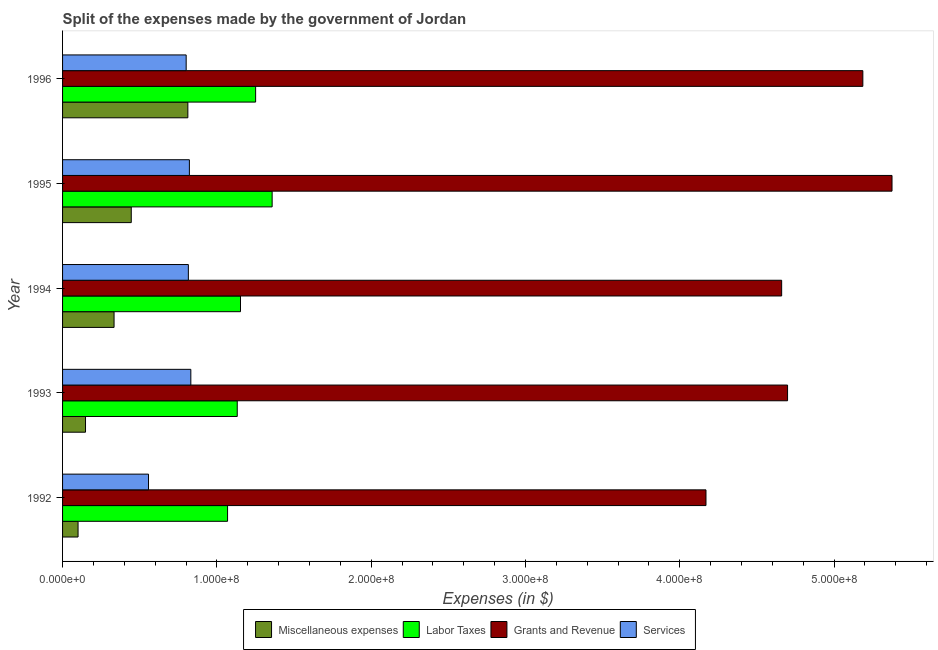How many different coloured bars are there?
Provide a short and direct response. 4. How many bars are there on the 1st tick from the top?
Your answer should be compact. 4. What is the label of the 3rd group of bars from the top?
Give a very brief answer. 1994. In how many cases, is the number of bars for a given year not equal to the number of legend labels?
Your answer should be very brief. 0. What is the amount spent on miscellaneous expenses in 1996?
Provide a short and direct response. 8.12e+07. Across all years, what is the maximum amount spent on services?
Your response must be concise. 8.31e+07. Across all years, what is the minimum amount spent on miscellaneous expenses?
Offer a very short reply. 1.00e+07. In which year was the amount spent on grants and revenue maximum?
Ensure brevity in your answer.  1995. In which year was the amount spent on services minimum?
Keep it short and to the point. 1992. What is the total amount spent on labor taxes in the graph?
Keep it short and to the point. 5.96e+08. What is the difference between the amount spent on labor taxes in 1993 and that in 1995?
Make the answer very short. -2.26e+07. What is the difference between the amount spent on services in 1993 and the amount spent on grants and revenue in 1996?
Offer a very short reply. -4.36e+08. What is the average amount spent on services per year?
Provide a succinct answer. 7.65e+07. In the year 1993, what is the difference between the amount spent on labor taxes and amount spent on grants and revenue?
Keep it short and to the point. -3.57e+08. What is the ratio of the amount spent on grants and revenue in 1993 to that in 1996?
Your answer should be very brief. 0.91. Is the amount spent on labor taxes in 1994 less than that in 1995?
Your response must be concise. Yes. What is the difference between the highest and the second highest amount spent on services?
Your answer should be compact. 9.30e+05. What is the difference between the highest and the lowest amount spent on miscellaneous expenses?
Keep it short and to the point. 7.12e+07. What does the 4th bar from the top in 1995 represents?
Keep it short and to the point. Miscellaneous expenses. What does the 1st bar from the bottom in 1996 represents?
Give a very brief answer. Miscellaneous expenses. How many bars are there?
Provide a short and direct response. 20. Are the values on the major ticks of X-axis written in scientific E-notation?
Your answer should be compact. Yes. Does the graph contain any zero values?
Your answer should be very brief. No. Does the graph contain grids?
Provide a succinct answer. No. Where does the legend appear in the graph?
Provide a succinct answer. Bottom center. What is the title of the graph?
Provide a succinct answer. Split of the expenses made by the government of Jordan. Does "Social Assistance" appear as one of the legend labels in the graph?
Give a very brief answer. No. What is the label or title of the X-axis?
Provide a succinct answer. Expenses (in $). What is the label or title of the Y-axis?
Your response must be concise. Year. What is the Expenses (in $) of Miscellaneous expenses in 1992?
Your response must be concise. 1.00e+07. What is the Expenses (in $) in Labor Taxes in 1992?
Provide a succinct answer. 1.07e+08. What is the Expenses (in $) in Grants and Revenue in 1992?
Your answer should be very brief. 4.17e+08. What is the Expenses (in $) in Services in 1992?
Provide a succinct answer. 5.57e+07. What is the Expenses (in $) of Miscellaneous expenses in 1993?
Make the answer very short. 1.49e+07. What is the Expenses (in $) of Labor Taxes in 1993?
Provide a succinct answer. 1.13e+08. What is the Expenses (in $) of Grants and Revenue in 1993?
Make the answer very short. 4.70e+08. What is the Expenses (in $) in Services in 1993?
Provide a short and direct response. 8.31e+07. What is the Expenses (in $) in Miscellaneous expenses in 1994?
Your response must be concise. 3.34e+07. What is the Expenses (in $) of Labor Taxes in 1994?
Give a very brief answer. 1.15e+08. What is the Expenses (in $) in Grants and Revenue in 1994?
Provide a succinct answer. 4.66e+08. What is the Expenses (in $) in Services in 1994?
Offer a terse response. 8.15e+07. What is the Expenses (in $) of Miscellaneous expenses in 1995?
Ensure brevity in your answer.  4.45e+07. What is the Expenses (in $) of Labor Taxes in 1995?
Your answer should be compact. 1.36e+08. What is the Expenses (in $) of Grants and Revenue in 1995?
Provide a succinct answer. 5.38e+08. What is the Expenses (in $) in Services in 1995?
Give a very brief answer. 8.22e+07. What is the Expenses (in $) of Miscellaneous expenses in 1996?
Your answer should be compact. 8.12e+07. What is the Expenses (in $) in Labor Taxes in 1996?
Offer a terse response. 1.25e+08. What is the Expenses (in $) in Grants and Revenue in 1996?
Give a very brief answer. 5.19e+08. What is the Expenses (in $) in Services in 1996?
Offer a terse response. 8.01e+07. Across all years, what is the maximum Expenses (in $) of Miscellaneous expenses?
Give a very brief answer. 8.12e+07. Across all years, what is the maximum Expenses (in $) of Labor Taxes?
Your answer should be compact. 1.36e+08. Across all years, what is the maximum Expenses (in $) of Grants and Revenue?
Give a very brief answer. 5.38e+08. Across all years, what is the maximum Expenses (in $) in Services?
Provide a succinct answer. 8.31e+07. Across all years, what is the minimum Expenses (in $) of Miscellaneous expenses?
Offer a very short reply. 1.00e+07. Across all years, what is the minimum Expenses (in $) in Labor Taxes?
Your response must be concise. 1.07e+08. Across all years, what is the minimum Expenses (in $) in Grants and Revenue?
Keep it short and to the point. 4.17e+08. Across all years, what is the minimum Expenses (in $) of Services?
Keep it short and to the point. 5.57e+07. What is the total Expenses (in $) in Miscellaneous expenses in the graph?
Ensure brevity in your answer.  1.84e+08. What is the total Expenses (in $) of Labor Taxes in the graph?
Make the answer very short. 5.96e+08. What is the total Expenses (in $) in Grants and Revenue in the graph?
Make the answer very short. 2.41e+09. What is the total Expenses (in $) of Services in the graph?
Give a very brief answer. 3.83e+08. What is the difference between the Expenses (in $) in Miscellaneous expenses in 1992 and that in 1993?
Your response must be concise. -4.83e+06. What is the difference between the Expenses (in $) of Labor Taxes in 1992 and that in 1993?
Your answer should be compact. -6.27e+06. What is the difference between the Expenses (in $) of Grants and Revenue in 1992 and that in 1993?
Offer a very short reply. -5.29e+07. What is the difference between the Expenses (in $) in Services in 1992 and that in 1993?
Provide a succinct answer. -2.74e+07. What is the difference between the Expenses (in $) of Miscellaneous expenses in 1992 and that in 1994?
Keep it short and to the point. -2.33e+07. What is the difference between the Expenses (in $) of Labor Taxes in 1992 and that in 1994?
Your answer should be very brief. -8.38e+06. What is the difference between the Expenses (in $) in Grants and Revenue in 1992 and that in 1994?
Offer a terse response. -4.90e+07. What is the difference between the Expenses (in $) of Services in 1992 and that in 1994?
Your answer should be compact. -2.58e+07. What is the difference between the Expenses (in $) of Miscellaneous expenses in 1992 and that in 1995?
Offer a terse response. -3.45e+07. What is the difference between the Expenses (in $) of Labor Taxes in 1992 and that in 1995?
Provide a succinct answer. -2.89e+07. What is the difference between the Expenses (in $) in Grants and Revenue in 1992 and that in 1995?
Keep it short and to the point. -1.21e+08. What is the difference between the Expenses (in $) in Services in 1992 and that in 1995?
Your response must be concise. -2.65e+07. What is the difference between the Expenses (in $) in Miscellaneous expenses in 1992 and that in 1996?
Offer a very short reply. -7.12e+07. What is the difference between the Expenses (in $) of Labor Taxes in 1992 and that in 1996?
Offer a very short reply. -1.82e+07. What is the difference between the Expenses (in $) in Grants and Revenue in 1992 and that in 1996?
Keep it short and to the point. -1.02e+08. What is the difference between the Expenses (in $) of Services in 1992 and that in 1996?
Make the answer very short. -2.44e+07. What is the difference between the Expenses (in $) in Miscellaneous expenses in 1993 and that in 1994?
Ensure brevity in your answer.  -1.85e+07. What is the difference between the Expenses (in $) of Labor Taxes in 1993 and that in 1994?
Keep it short and to the point. -2.11e+06. What is the difference between the Expenses (in $) in Grants and Revenue in 1993 and that in 1994?
Offer a very short reply. 3.83e+06. What is the difference between the Expenses (in $) of Services in 1993 and that in 1994?
Offer a very short reply. 1.60e+06. What is the difference between the Expenses (in $) in Miscellaneous expenses in 1993 and that in 1995?
Keep it short and to the point. -2.96e+07. What is the difference between the Expenses (in $) in Labor Taxes in 1993 and that in 1995?
Offer a terse response. -2.26e+07. What is the difference between the Expenses (in $) of Grants and Revenue in 1993 and that in 1995?
Provide a short and direct response. -6.77e+07. What is the difference between the Expenses (in $) in Services in 1993 and that in 1995?
Ensure brevity in your answer.  9.30e+05. What is the difference between the Expenses (in $) in Miscellaneous expenses in 1993 and that in 1996?
Your answer should be compact. -6.63e+07. What is the difference between the Expenses (in $) of Labor Taxes in 1993 and that in 1996?
Ensure brevity in your answer.  -1.19e+07. What is the difference between the Expenses (in $) in Grants and Revenue in 1993 and that in 1996?
Your answer should be very brief. -4.88e+07. What is the difference between the Expenses (in $) in Services in 1993 and that in 1996?
Make the answer very short. 3.02e+06. What is the difference between the Expenses (in $) of Miscellaneous expenses in 1994 and that in 1995?
Provide a short and direct response. -1.12e+07. What is the difference between the Expenses (in $) of Labor Taxes in 1994 and that in 1995?
Give a very brief answer. -2.05e+07. What is the difference between the Expenses (in $) in Grants and Revenue in 1994 and that in 1995?
Your answer should be compact. -7.15e+07. What is the difference between the Expenses (in $) of Services in 1994 and that in 1995?
Give a very brief answer. -6.70e+05. What is the difference between the Expenses (in $) of Miscellaneous expenses in 1994 and that in 1996?
Give a very brief answer. -4.78e+07. What is the difference between the Expenses (in $) of Labor Taxes in 1994 and that in 1996?
Offer a very short reply. -9.80e+06. What is the difference between the Expenses (in $) of Grants and Revenue in 1994 and that in 1996?
Give a very brief answer. -5.26e+07. What is the difference between the Expenses (in $) of Services in 1994 and that in 1996?
Give a very brief answer. 1.42e+06. What is the difference between the Expenses (in $) in Miscellaneous expenses in 1995 and that in 1996?
Provide a short and direct response. -3.67e+07. What is the difference between the Expenses (in $) in Labor Taxes in 1995 and that in 1996?
Provide a succinct answer. 1.07e+07. What is the difference between the Expenses (in $) in Grants and Revenue in 1995 and that in 1996?
Your response must be concise. 1.89e+07. What is the difference between the Expenses (in $) of Services in 1995 and that in 1996?
Ensure brevity in your answer.  2.09e+06. What is the difference between the Expenses (in $) of Miscellaneous expenses in 1992 and the Expenses (in $) of Labor Taxes in 1993?
Provide a short and direct response. -1.03e+08. What is the difference between the Expenses (in $) in Miscellaneous expenses in 1992 and the Expenses (in $) in Grants and Revenue in 1993?
Provide a succinct answer. -4.60e+08. What is the difference between the Expenses (in $) of Miscellaneous expenses in 1992 and the Expenses (in $) of Services in 1993?
Your response must be concise. -7.31e+07. What is the difference between the Expenses (in $) of Labor Taxes in 1992 and the Expenses (in $) of Grants and Revenue in 1993?
Your answer should be compact. -3.63e+08. What is the difference between the Expenses (in $) in Labor Taxes in 1992 and the Expenses (in $) in Services in 1993?
Give a very brief answer. 2.38e+07. What is the difference between the Expenses (in $) of Grants and Revenue in 1992 and the Expenses (in $) of Services in 1993?
Offer a terse response. 3.34e+08. What is the difference between the Expenses (in $) in Miscellaneous expenses in 1992 and the Expenses (in $) in Labor Taxes in 1994?
Your answer should be compact. -1.05e+08. What is the difference between the Expenses (in $) in Miscellaneous expenses in 1992 and the Expenses (in $) in Grants and Revenue in 1994?
Offer a terse response. -4.56e+08. What is the difference between the Expenses (in $) of Miscellaneous expenses in 1992 and the Expenses (in $) of Services in 1994?
Your response must be concise. -7.15e+07. What is the difference between the Expenses (in $) in Labor Taxes in 1992 and the Expenses (in $) in Grants and Revenue in 1994?
Offer a very short reply. -3.59e+08. What is the difference between the Expenses (in $) of Labor Taxes in 1992 and the Expenses (in $) of Services in 1994?
Offer a very short reply. 2.54e+07. What is the difference between the Expenses (in $) of Grants and Revenue in 1992 and the Expenses (in $) of Services in 1994?
Provide a succinct answer. 3.35e+08. What is the difference between the Expenses (in $) of Miscellaneous expenses in 1992 and the Expenses (in $) of Labor Taxes in 1995?
Provide a short and direct response. -1.26e+08. What is the difference between the Expenses (in $) of Miscellaneous expenses in 1992 and the Expenses (in $) of Grants and Revenue in 1995?
Give a very brief answer. -5.27e+08. What is the difference between the Expenses (in $) in Miscellaneous expenses in 1992 and the Expenses (in $) in Services in 1995?
Offer a very short reply. -7.22e+07. What is the difference between the Expenses (in $) of Labor Taxes in 1992 and the Expenses (in $) of Grants and Revenue in 1995?
Your answer should be compact. -4.31e+08. What is the difference between the Expenses (in $) of Labor Taxes in 1992 and the Expenses (in $) of Services in 1995?
Make the answer very short. 2.47e+07. What is the difference between the Expenses (in $) in Grants and Revenue in 1992 and the Expenses (in $) in Services in 1995?
Offer a very short reply. 3.35e+08. What is the difference between the Expenses (in $) of Miscellaneous expenses in 1992 and the Expenses (in $) of Labor Taxes in 1996?
Offer a terse response. -1.15e+08. What is the difference between the Expenses (in $) in Miscellaneous expenses in 1992 and the Expenses (in $) in Grants and Revenue in 1996?
Give a very brief answer. -5.09e+08. What is the difference between the Expenses (in $) of Miscellaneous expenses in 1992 and the Expenses (in $) of Services in 1996?
Keep it short and to the point. -7.01e+07. What is the difference between the Expenses (in $) of Labor Taxes in 1992 and the Expenses (in $) of Grants and Revenue in 1996?
Keep it short and to the point. -4.12e+08. What is the difference between the Expenses (in $) in Labor Taxes in 1992 and the Expenses (in $) in Services in 1996?
Your answer should be compact. 2.68e+07. What is the difference between the Expenses (in $) in Grants and Revenue in 1992 and the Expenses (in $) in Services in 1996?
Your answer should be compact. 3.37e+08. What is the difference between the Expenses (in $) of Miscellaneous expenses in 1993 and the Expenses (in $) of Labor Taxes in 1994?
Offer a very short reply. -1.00e+08. What is the difference between the Expenses (in $) of Miscellaneous expenses in 1993 and the Expenses (in $) of Grants and Revenue in 1994?
Keep it short and to the point. -4.51e+08. What is the difference between the Expenses (in $) of Miscellaneous expenses in 1993 and the Expenses (in $) of Services in 1994?
Your answer should be compact. -6.66e+07. What is the difference between the Expenses (in $) of Labor Taxes in 1993 and the Expenses (in $) of Grants and Revenue in 1994?
Keep it short and to the point. -3.53e+08. What is the difference between the Expenses (in $) in Labor Taxes in 1993 and the Expenses (in $) in Services in 1994?
Keep it short and to the point. 3.17e+07. What is the difference between the Expenses (in $) in Grants and Revenue in 1993 and the Expenses (in $) in Services in 1994?
Keep it short and to the point. 3.88e+08. What is the difference between the Expenses (in $) in Miscellaneous expenses in 1993 and the Expenses (in $) in Labor Taxes in 1995?
Provide a succinct answer. -1.21e+08. What is the difference between the Expenses (in $) in Miscellaneous expenses in 1993 and the Expenses (in $) in Grants and Revenue in 1995?
Your answer should be compact. -5.23e+08. What is the difference between the Expenses (in $) of Miscellaneous expenses in 1993 and the Expenses (in $) of Services in 1995?
Provide a short and direct response. -6.73e+07. What is the difference between the Expenses (in $) in Labor Taxes in 1993 and the Expenses (in $) in Grants and Revenue in 1995?
Provide a short and direct response. -4.24e+08. What is the difference between the Expenses (in $) in Labor Taxes in 1993 and the Expenses (in $) in Services in 1995?
Make the answer very short. 3.10e+07. What is the difference between the Expenses (in $) in Grants and Revenue in 1993 and the Expenses (in $) in Services in 1995?
Make the answer very short. 3.88e+08. What is the difference between the Expenses (in $) of Miscellaneous expenses in 1993 and the Expenses (in $) of Labor Taxes in 1996?
Your answer should be very brief. -1.10e+08. What is the difference between the Expenses (in $) in Miscellaneous expenses in 1993 and the Expenses (in $) in Grants and Revenue in 1996?
Keep it short and to the point. -5.04e+08. What is the difference between the Expenses (in $) in Miscellaneous expenses in 1993 and the Expenses (in $) in Services in 1996?
Your answer should be very brief. -6.52e+07. What is the difference between the Expenses (in $) in Labor Taxes in 1993 and the Expenses (in $) in Grants and Revenue in 1996?
Give a very brief answer. -4.05e+08. What is the difference between the Expenses (in $) of Labor Taxes in 1993 and the Expenses (in $) of Services in 1996?
Your answer should be compact. 3.31e+07. What is the difference between the Expenses (in $) of Grants and Revenue in 1993 and the Expenses (in $) of Services in 1996?
Keep it short and to the point. 3.90e+08. What is the difference between the Expenses (in $) in Miscellaneous expenses in 1994 and the Expenses (in $) in Labor Taxes in 1995?
Offer a terse response. -1.02e+08. What is the difference between the Expenses (in $) in Miscellaneous expenses in 1994 and the Expenses (in $) in Grants and Revenue in 1995?
Ensure brevity in your answer.  -5.04e+08. What is the difference between the Expenses (in $) in Miscellaneous expenses in 1994 and the Expenses (in $) in Services in 1995?
Keep it short and to the point. -4.88e+07. What is the difference between the Expenses (in $) in Labor Taxes in 1994 and the Expenses (in $) in Grants and Revenue in 1995?
Offer a terse response. -4.22e+08. What is the difference between the Expenses (in $) in Labor Taxes in 1994 and the Expenses (in $) in Services in 1995?
Provide a succinct answer. 3.31e+07. What is the difference between the Expenses (in $) in Grants and Revenue in 1994 and the Expenses (in $) in Services in 1995?
Provide a succinct answer. 3.84e+08. What is the difference between the Expenses (in $) of Miscellaneous expenses in 1994 and the Expenses (in $) of Labor Taxes in 1996?
Your answer should be compact. -9.17e+07. What is the difference between the Expenses (in $) in Miscellaneous expenses in 1994 and the Expenses (in $) in Grants and Revenue in 1996?
Offer a very short reply. -4.85e+08. What is the difference between the Expenses (in $) in Miscellaneous expenses in 1994 and the Expenses (in $) in Services in 1996?
Ensure brevity in your answer.  -4.67e+07. What is the difference between the Expenses (in $) of Labor Taxes in 1994 and the Expenses (in $) of Grants and Revenue in 1996?
Provide a short and direct response. -4.03e+08. What is the difference between the Expenses (in $) in Labor Taxes in 1994 and the Expenses (in $) in Services in 1996?
Give a very brief answer. 3.52e+07. What is the difference between the Expenses (in $) in Grants and Revenue in 1994 and the Expenses (in $) in Services in 1996?
Ensure brevity in your answer.  3.86e+08. What is the difference between the Expenses (in $) in Miscellaneous expenses in 1995 and the Expenses (in $) in Labor Taxes in 1996?
Offer a terse response. -8.06e+07. What is the difference between the Expenses (in $) in Miscellaneous expenses in 1995 and the Expenses (in $) in Grants and Revenue in 1996?
Make the answer very short. -4.74e+08. What is the difference between the Expenses (in $) in Miscellaneous expenses in 1995 and the Expenses (in $) in Services in 1996?
Your response must be concise. -3.56e+07. What is the difference between the Expenses (in $) in Labor Taxes in 1995 and the Expenses (in $) in Grants and Revenue in 1996?
Make the answer very short. -3.83e+08. What is the difference between the Expenses (in $) of Labor Taxes in 1995 and the Expenses (in $) of Services in 1996?
Your response must be concise. 5.57e+07. What is the difference between the Expenses (in $) in Grants and Revenue in 1995 and the Expenses (in $) in Services in 1996?
Give a very brief answer. 4.57e+08. What is the average Expenses (in $) in Miscellaneous expenses per year?
Your response must be concise. 3.68e+07. What is the average Expenses (in $) of Labor Taxes per year?
Provide a succinct answer. 1.19e+08. What is the average Expenses (in $) of Grants and Revenue per year?
Offer a very short reply. 4.82e+08. What is the average Expenses (in $) of Services per year?
Keep it short and to the point. 7.65e+07. In the year 1992, what is the difference between the Expenses (in $) in Miscellaneous expenses and Expenses (in $) in Labor Taxes?
Keep it short and to the point. -9.69e+07. In the year 1992, what is the difference between the Expenses (in $) in Miscellaneous expenses and Expenses (in $) in Grants and Revenue?
Keep it short and to the point. -4.07e+08. In the year 1992, what is the difference between the Expenses (in $) in Miscellaneous expenses and Expenses (in $) in Services?
Your response must be concise. -4.57e+07. In the year 1992, what is the difference between the Expenses (in $) of Labor Taxes and Expenses (in $) of Grants and Revenue?
Provide a short and direct response. -3.10e+08. In the year 1992, what is the difference between the Expenses (in $) in Labor Taxes and Expenses (in $) in Services?
Give a very brief answer. 5.12e+07. In the year 1992, what is the difference between the Expenses (in $) in Grants and Revenue and Expenses (in $) in Services?
Make the answer very short. 3.61e+08. In the year 1993, what is the difference between the Expenses (in $) of Miscellaneous expenses and Expenses (in $) of Labor Taxes?
Make the answer very short. -9.83e+07. In the year 1993, what is the difference between the Expenses (in $) of Miscellaneous expenses and Expenses (in $) of Grants and Revenue?
Make the answer very short. -4.55e+08. In the year 1993, what is the difference between the Expenses (in $) of Miscellaneous expenses and Expenses (in $) of Services?
Your answer should be compact. -6.82e+07. In the year 1993, what is the difference between the Expenses (in $) in Labor Taxes and Expenses (in $) in Grants and Revenue?
Provide a short and direct response. -3.57e+08. In the year 1993, what is the difference between the Expenses (in $) in Labor Taxes and Expenses (in $) in Services?
Your answer should be very brief. 3.01e+07. In the year 1993, what is the difference between the Expenses (in $) in Grants and Revenue and Expenses (in $) in Services?
Your response must be concise. 3.87e+08. In the year 1994, what is the difference between the Expenses (in $) in Miscellaneous expenses and Expenses (in $) in Labor Taxes?
Your response must be concise. -8.19e+07. In the year 1994, what is the difference between the Expenses (in $) of Miscellaneous expenses and Expenses (in $) of Grants and Revenue?
Make the answer very short. -4.33e+08. In the year 1994, what is the difference between the Expenses (in $) of Miscellaneous expenses and Expenses (in $) of Services?
Offer a very short reply. -4.82e+07. In the year 1994, what is the difference between the Expenses (in $) of Labor Taxes and Expenses (in $) of Grants and Revenue?
Make the answer very short. -3.51e+08. In the year 1994, what is the difference between the Expenses (in $) of Labor Taxes and Expenses (in $) of Services?
Make the answer very short. 3.38e+07. In the year 1994, what is the difference between the Expenses (in $) in Grants and Revenue and Expenses (in $) in Services?
Provide a succinct answer. 3.84e+08. In the year 1995, what is the difference between the Expenses (in $) in Miscellaneous expenses and Expenses (in $) in Labor Taxes?
Give a very brief answer. -9.13e+07. In the year 1995, what is the difference between the Expenses (in $) of Miscellaneous expenses and Expenses (in $) of Grants and Revenue?
Ensure brevity in your answer.  -4.93e+08. In the year 1995, what is the difference between the Expenses (in $) in Miscellaneous expenses and Expenses (in $) in Services?
Keep it short and to the point. -3.77e+07. In the year 1995, what is the difference between the Expenses (in $) of Labor Taxes and Expenses (in $) of Grants and Revenue?
Provide a short and direct response. -4.02e+08. In the year 1995, what is the difference between the Expenses (in $) of Labor Taxes and Expenses (in $) of Services?
Your answer should be compact. 5.36e+07. In the year 1995, what is the difference between the Expenses (in $) in Grants and Revenue and Expenses (in $) in Services?
Offer a very short reply. 4.55e+08. In the year 1996, what is the difference between the Expenses (in $) in Miscellaneous expenses and Expenses (in $) in Labor Taxes?
Ensure brevity in your answer.  -4.39e+07. In the year 1996, what is the difference between the Expenses (in $) of Miscellaneous expenses and Expenses (in $) of Grants and Revenue?
Make the answer very short. -4.37e+08. In the year 1996, what is the difference between the Expenses (in $) of Miscellaneous expenses and Expenses (in $) of Services?
Offer a terse response. 1.10e+06. In the year 1996, what is the difference between the Expenses (in $) of Labor Taxes and Expenses (in $) of Grants and Revenue?
Offer a very short reply. -3.94e+08. In the year 1996, what is the difference between the Expenses (in $) in Labor Taxes and Expenses (in $) in Services?
Give a very brief answer. 4.50e+07. In the year 1996, what is the difference between the Expenses (in $) in Grants and Revenue and Expenses (in $) in Services?
Keep it short and to the point. 4.39e+08. What is the ratio of the Expenses (in $) in Miscellaneous expenses in 1992 to that in 1993?
Provide a succinct answer. 0.68. What is the ratio of the Expenses (in $) in Labor Taxes in 1992 to that in 1993?
Make the answer very short. 0.94. What is the ratio of the Expenses (in $) in Grants and Revenue in 1992 to that in 1993?
Make the answer very short. 0.89. What is the ratio of the Expenses (in $) in Services in 1992 to that in 1993?
Ensure brevity in your answer.  0.67. What is the ratio of the Expenses (in $) in Miscellaneous expenses in 1992 to that in 1994?
Offer a very short reply. 0.3. What is the ratio of the Expenses (in $) in Labor Taxes in 1992 to that in 1994?
Your answer should be very brief. 0.93. What is the ratio of the Expenses (in $) in Grants and Revenue in 1992 to that in 1994?
Give a very brief answer. 0.89. What is the ratio of the Expenses (in $) of Services in 1992 to that in 1994?
Provide a succinct answer. 0.68. What is the ratio of the Expenses (in $) in Miscellaneous expenses in 1992 to that in 1995?
Offer a terse response. 0.23. What is the ratio of the Expenses (in $) in Labor Taxes in 1992 to that in 1995?
Offer a terse response. 0.79. What is the ratio of the Expenses (in $) of Grants and Revenue in 1992 to that in 1995?
Make the answer very short. 0.78. What is the ratio of the Expenses (in $) of Services in 1992 to that in 1995?
Your response must be concise. 0.68. What is the ratio of the Expenses (in $) of Miscellaneous expenses in 1992 to that in 1996?
Provide a succinct answer. 0.12. What is the ratio of the Expenses (in $) of Labor Taxes in 1992 to that in 1996?
Offer a very short reply. 0.85. What is the ratio of the Expenses (in $) in Grants and Revenue in 1992 to that in 1996?
Keep it short and to the point. 0.8. What is the ratio of the Expenses (in $) in Services in 1992 to that in 1996?
Give a very brief answer. 0.7. What is the ratio of the Expenses (in $) in Miscellaneous expenses in 1993 to that in 1994?
Make the answer very short. 0.45. What is the ratio of the Expenses (in $) of Labor Taxes in 1993 to that in 1994?
Your response must be concise. 0.98. What is the ratio of the Expenses (in $) of Grants and Revenue in 1993 to that in 1994?
Your answer should be compact. 1.01. What is the ratio of the Expenses (in $) of Services in 1993 to that in 1994?
Provide a short and direct response. 1.02. What is the ratio of the Expenses (in $) of Miscellaneous expenses in 1993 to that in 1995?
Your answer should be compact. 0.33. What is the ratio of the Expenses (in $) of Labor Taxes in 1993 to that in 1995?
Give a very brief answer. 0.83. What is the ratio of the Expenses (in $) in Grants and Revenue in 1993 to that in 1995?
Your answer should be compact. 0.87. What is the ratio of the Expenses (in $) in Services in 1993 to that in 1995?
Ensure brevity in your answer.  1.01. What is the ratio of the Expenses (in $) in Miscellaneous expenses in 1993 to that in 1996?
Make the answer very short. 0.18. What is the ratio of the Expenses (in $) of Labor Taxes in 1993 to that in 1996?
Provide a short and direct response. 0.9. What is the ratio of the Expenses (in $) of Grants and Revenue in 1993 to that in 1996?
Your answer should be very brief. 0.91. What is the ratio of the Expenses (in $) of Services in 1993 to that in 1996?
Your answer should be very brief. 1.04. What is the ratio of the Expenses (in $) of Miscellaneous expenses in 1994 to that in 1995?
Provide a succinct answer. 0.75. What is the ratio of the Expenses (in $) of Labor Taxes in 1994 to that in 1995?
Make the answer very short. 0.85. What is the ratio of the Expenses (in $) in Grants and Revenue in 1994 to that in 1995?
Offer a terse response. 0.87. What is the ratio of the Expenses (in $) of Services in 1994 to that in 1995?
Keep it short and to the point. 0.99. What is the ratio of the Expenses (in $) in Miscellaneous expenses in 1994 to that in 1996?
Keep it short and to the point. 0.41. What is the ratio of the Expenses (in $) in Labor Taxes in 1994 to that in 1996?
Your response must be concise. 0.92. What is the ratio of the Expenses (in $) in Grants and Revenue in 1994 to that in 1996?
Offer a very short reply. 0.9. What is the ratio of the Expenses (in $) in Services in 1994 to that in 1996?
Your answer should be very brief. 1.02. What is the ratio of the Expenses (in $) in Miscellaneous expenses in 1995 to that in 1996?
Offer a very short reply. 0.55. What is the ratio of the Expenses (in $) of Labor Taxes in 1995 to that in 1996?
Provide a short and direct response. 1.09. What is the ratio of the Expenses (in $) of Grants and Revenue in 1995 to that in 1996?
Provide a succinct answer. 1.04. What is the ratio of the Expenses (in $) in Services in 1995 to that in 1996?
Offer a very short reply. 1.03. What is the difference between the highest and the second highest Expenses (in $) in Miscellaneous expenses?
Provide a short and direct response. 3.67e+07. What is the difference between the highest and the second highest Expenses (in $) in Labor Taxes?
Ensure brevity in your answer.  1.07e+07. What is the difference between the highest and the second highest Expenses (in $) of Grants and Revenue?
Give a very brief answer. 1.89e+07. What is the difference between the highest and the second highest Expenses (in $) of Services?
Keep it short and to the point. 9.30e+05. What is the difference between the highest and the lowest Expenses (in $) of Miscellaneous expenses?
Provide a short and direct response. 7.12e+07. What is the difference between the highest and the lowest Expenses (in $) of Labor Taxes?
Provide a succinct answer. 2.89e+07. What is the difference between the highest and the lowest Expenses (in $) of Grants and Revenue?
Offer a terse response. 1.21e+08. What is the difference between the highest and the lowest Expenses (in $) in Services?
Provide a succinct answer. 2.74e+07. 